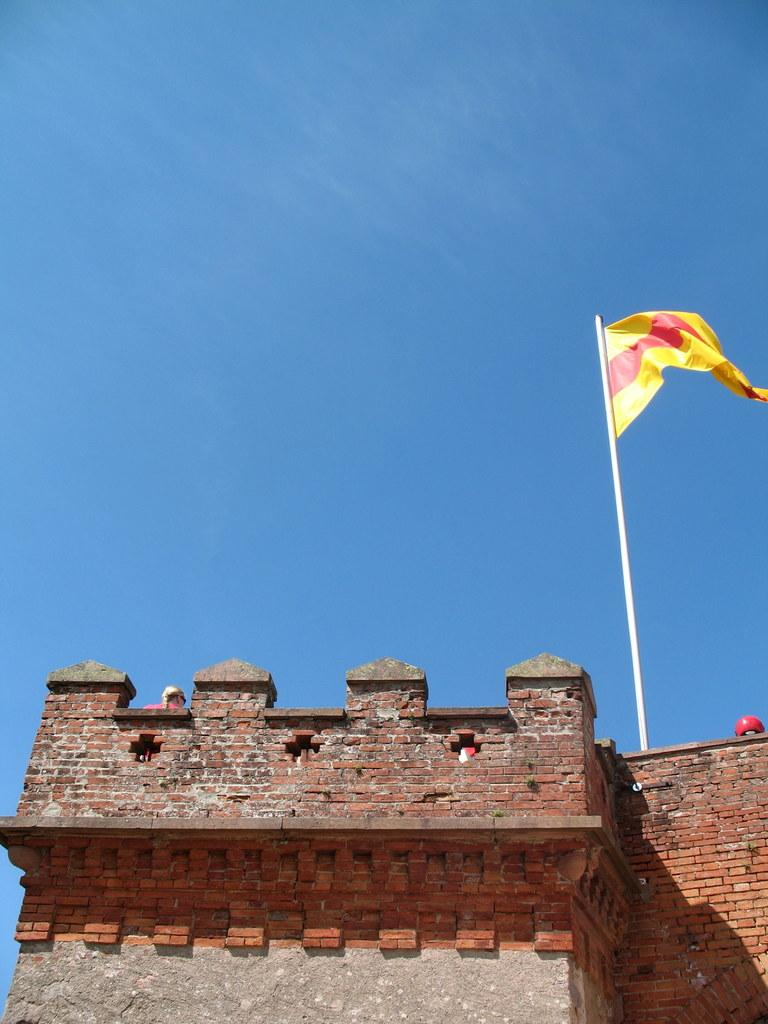What structure is present in the image? There is a building in the image. Can you describe any activity or person on the building? A person is visible on the building. What is attached to the building? There is a pole with a flag on the building. What is visible at the top of the image? The sky is visible at the top of the image. How many flocks of birds can be seen flying over the building in the image? There are no flocks of birds visible in the image. What time of day is depicted in the image? The time of day cannot be determined from the image alone. 